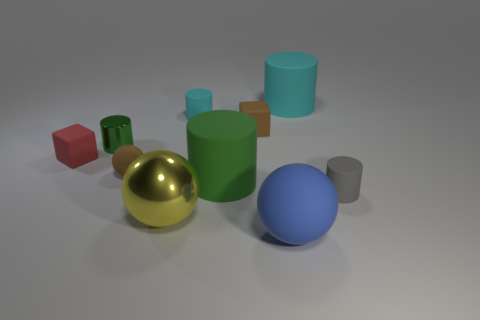Subtract all tiny gray rubber cylinders. How many cylinders are left? 4 Subtract all yellow spheres. How many spheres are left? 2 Subtract all blocks. How many objects are left? 8 Subtract 2 blocks. How many blocks are left? 0 Subtract all gray cubes. How many green cylinders are left? 2 Subtract all big yellow objects. Subtract all small cyan cylinders. How many objects are left? 8 Add 3 tiny red blocks. How many tiny red blocks are left? 4 Add 6 cyan cylinders. How many cyan cylinders exist? 8 Subtract 0 yellow blocks. How many objects are left? 10 Subtract all gray blocks. Subtract all cyan spheres. How many blocks are left? 2 